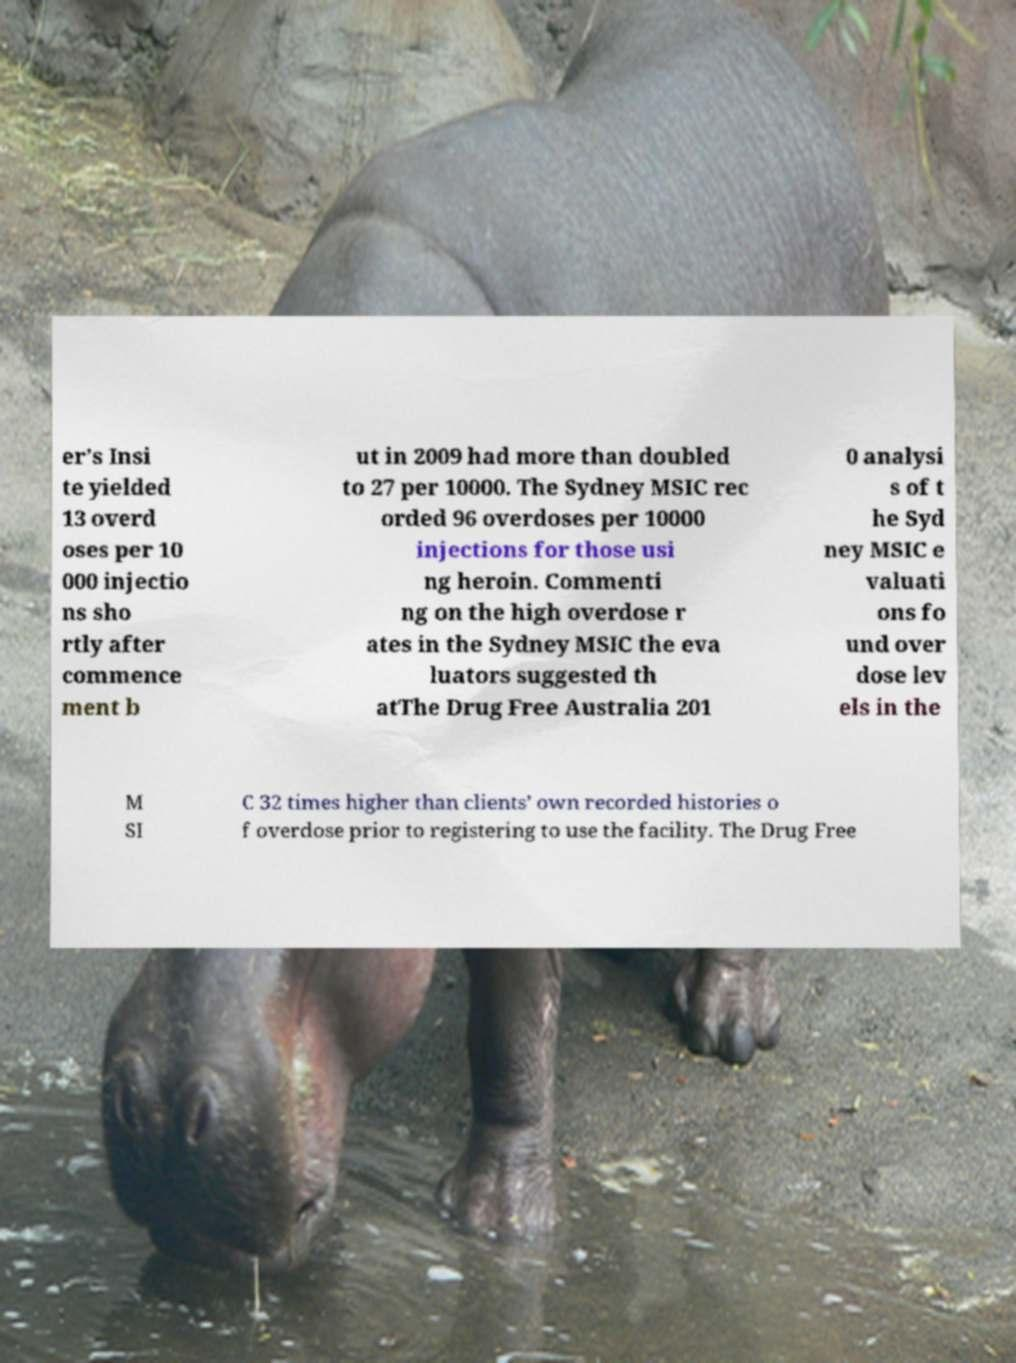What messages or text are displayed in this image? I need them in a readable, typed format. er’s Insi te yielded 13 overd oses per 10 000 injectio ns sho rtly after commence ment b ut in 2009 had more than doubled to 27 per 10000. The Sydney MSIC rec orded 96 overdoses per 10000 injections for those usi ng heroin. Commenti ng on the high overdose r ates in the Sydney MSIC the eva luators suggested th atThe Drug Free Australia 201 0 analysi s of t he Syd ney MSIC e valuati ons fo und over dose lev els in the M SI C 32 times higher than clients’ own recorded histories o f overdose prior to registering to use the facility. The Drug Free 